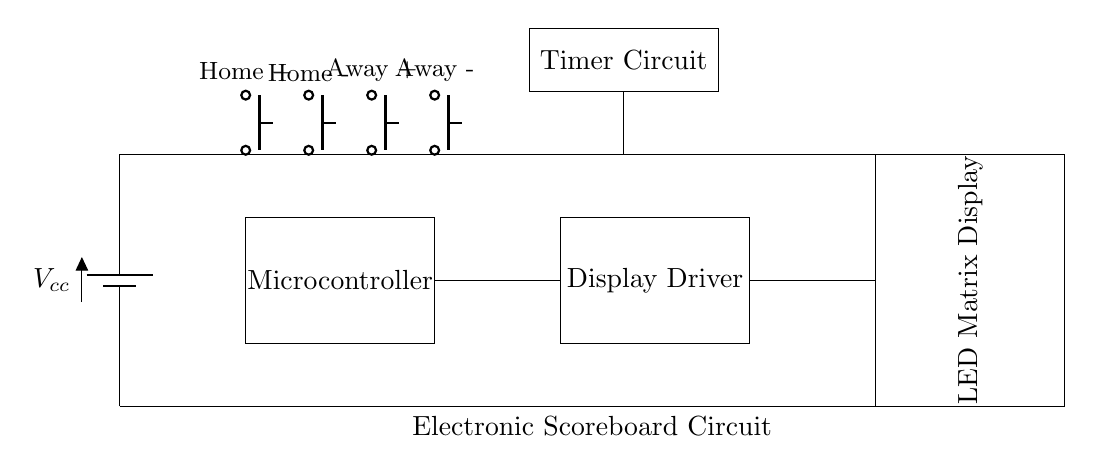What is the main power supply voltage present in the circuit? The circuit shows a battery symbol labeled Vcc, which typically denotes the power supply voltage needed for operation. While the exact value is not provided, it is common for microcontroller circuits to operate at 5 volts or higher.
Answer: Vcc What component controls the display? The display driver is the component responsible for controlling the LED matrix display, as indicated in its label. It acts as an interface between the microcontroller and the display.
Answer: Display Driver How many push buttons are used to adjust the scores? There are four push buttons provided in the circuit, indicated by their placement near the microcontroller. They are labeled Home +, Home -, Away +, and Away -.
Answer: Four What is the function of the timer circuit in this scoreboard? The timer circuit, shown in the diagram, is typically used to keep track of the game time. It would interact with the scores and other components to ensure accurate timekeeping during the match.
Answer: Timer Circuit Which component connects the microcontroller to the display driver? The connection between the microcontroller and the display driver is represented by a line drawn horizontally between them in the diagram, indicating they are wired together for communication.
Answer: Microcontroller 